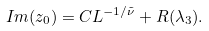Convert formula to latex. <formula><loc_0><loc_0><loc_500><loc_500>I m ( z _ { 0 } ) = C L ^ { - 1 / { \tilde { \nu } } } + R ( \lambda _ { 3 } ) .</formula> 